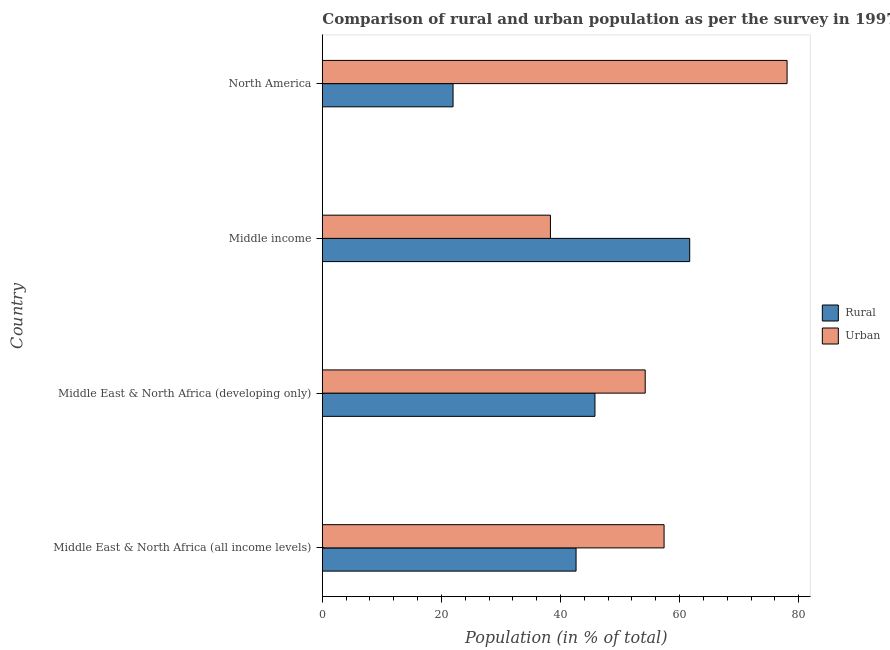Are the number of bars per tick equal to the number of legend labels?
Your answer should be very brief. Yes. How many bars are there on the 1st tick from the top?
Keep it short and to the point. 2. What is the urban population in Middle East & North Africa (all income levels)?
Provide a short and direct response. 57.39. Across all countries, what is the maximum rural population?
Your answer should be very brief. 61.69. Across all countries, what is the minimum rural population?
Ensure brevity in your answer.  21.95. In which country was the rural population maximum?
Offer a terse response. Middle income. What is the total urban population in the graph?
Offer a very short reply. 227.96. What is the difference between the urban population in Middle East & North Africa (all income levels) and that in Middle income?
Give a very brief answer. 19.08. What is the difference between the urban population in Middle income and the rural population in North America?
Your response must be concise. 16.35. What is the average rural population per country?
Make the answer very short. 43.01. What is the difference between the urban population and rural population in Middle income?
Your answer should be compact. -23.39. Is the difference between the urban population in Middle income and North America greater than the difference between the rural population in Middle income and North America?
Offer a terse response. No. What is the difference between the highest and the second highest urban population?
Offer a terse response. 20.66. What is the difference between the highest and the lowest urban population?
Ensure brevity in your answer.  39.74. What does the 2nd bar from the top in North America represents?
Ensure brevity in your answer.  Rural. What does the 1st bar from the bottom in Middle East & North Africa (all income levels) represents?
Your response must be concise. Rural. How many bars are there?
Your response must be concise. 8. Are all the bars in the graph horizontal?
Your answer should be compact. Yes. How many countries are there in the graph?
Give a very brief answer. 4. What is the difference between two consecutive major ticks on the X-axis?
Your answer should be compact. 20. Does the graph contain any zero values?
Ensure brevity in your answer.  No. Does the graph contain grids?
Provide a succinct answer. No. How many legend labels are there?
Ensure brevity in your answer.  2. What is the title of the graph?
Give a very brief answer. Comparison of rural and urban population as per the survey in 1997 census. Does "Diarrhea" appear as one of the legend labels in the graph?
Give a very brief answer. No. What is the label or title of the X-axis?
Keep it short and to the point. Population (in % of total). What is the label or title of the Y-axis?
Keep it short and to the point. Country. What is the Population (in % of total) in Rural in Middle East & North Africa (all income levels)?
Offer a terse response. 42.61. What is the Population (in % of total) of Urban in Middle East & North Africa (all income levels)?
Your answer should be very brief. 57.39. What is the Population (in % of total) in Rural in Middle East & North Africa (developing only)?
Keep it short and to the point. 45.78. What is the Population (in % of total) in Urban in Middle East & North Africa (developing only)?
Your response must be concise. 54.22. What is the Population (in % of total) in Rural in Middle income?
Ensure brevity in your answer.  61.69. What is the Population (in % of total) in Urban in Middle income?
Ensure brevity in your answer.  38.31. What is the Population (in % of total) in Rural in North America?
Provide a succinct answer. 21.95. What is the Population (in % of total) of Urban in North America?
Your answer should be compact. 78.05. Across all countries, what is the maximum Population (in % of total) of Rural?
Offer a terse response. 61.69. Across all countries, what is the maximum Population (in % of total) in Urban?
Provide a short and direct response. 78.05. Across all countries, what is the minimum Population (in % of total) in Rural?
Keep it short and to the point. 21.95. Across all countries, what is the minimum Population (in % of total) of Urban?
Your answer should be compact. 38.31. What is the total Population (in % of total) in Rural in the graph?
Your answer should be compact. 172.04. What is the total Population (in % of total) in Urban in the graph?
Ensure brevity in your answer.  227.96. What is the difference between the Population (in % of total) in Rural in Middle East & North Africa (all income levels) and that in Middle East & North Africa (developing only)?
Your answer should be compact. -3.17. What is the difference between the Population (in % of total) of Urban in Middle East & North Africa (all income levels) and that in Middle East & North Africa (developing only)?
Your answer should be very brief. 3.17. What is the difference between the Population (in % of total) of Rural in Middle East & North Africa (all income levels) and that in Middle income?
Offer a terse response. -19.08. What is the difference between the Population (in % of total) in Urban in Middle East & North Africa (all income levels) and that in Middle income?
Offer a terse response. 19.08. What is the difference between the Population (in % of total) of Rural in Middle East & North Africa (all income levels) and that in North America?
Your answer should be compact. 20.65. What is the difference between the Population (in % of total) in Urban in Middle East & North Africa (all income levels) and that in North America?
Make the answer very short. -20.65. What is the difference between the Population (in % of total) of Rural in Middle East & North Africa (developing only) and that in Middle income?
Ensure brevity in your answer.  -15.91. What is the difference between the Population (in % of total) in Urban in Middle East & North Africa (developing only) and that in Middle income?
Provide a succinct answer. 15.91. What is the difference between the Population (in % of total) in Rural in Middle East & North Africa (developing only) and that in North America?
Offer a terse response. 23.83. What is the difference between the Population (in % of total) in Urban in Middle East & North Africa (developing only) and that in North America?
Your response must be concise. -23.83. What is the difference between the Population (in % of total) in Rural in Middle income and that in North America?
Your response must be concise. 39.74. What is the difference between the Population (in % of total) of Urban in Middle income and that in North America?
Offer a very short reply. -39.74. What is the difference between the Population (in % of total) of Rural in Middle East & North Africa (all income levels) and the Population (in % of total) of Urban in Middle East & North Africa (developing only)?
Provide a short and direct response. -11.61. What is the difference between the Population (in % of total) of Rural in Middle East & North Africa (all income levels) and the Population (in % of total) of Urban in Middle income?
Your answer should be compact. 4.3. What is the difference between the Population (in % of total) of Rural in Middle East & North Africa (all income levels) and the Population (in % of total) of Urban in North America?
Ensure brevity in your answer.  -35.44. What is the difference between the Population (in % of total) in Rural in Middle East & North Africa (developing only) and the Population (in % of total) in Urban in Middle income?
Give a very brief answer. 7.48. What is the difference between the Population (in % of total) of Rural in Middle East & North Africa (developing only) and the Population (in % of total) of Urban in North America?
Offer a terse response. -32.26. What is the difference between the Population (in % of total) of Rural in Middle income and the Population (in % of total) of Urban in North America?
Provide a short and direct response. -16.35. What is the average Population (in % of total) of Rural per country?
Make the answer very short. 43.01. What is the average Population (in % of total) in Urban per country?
Ensure brevity in your answer.  56.99. What is the difference between the Population (in % of total) of Rural and Population (in % of total) of Urban in Middle East & North Africa (all income levels)?
Your response must be concise. -14.78. What is the difference between the Population (in % of total) of Rural and Population (in % of total) of Urban in Middle East & North Africa (developing only)?
Make the answer very short. -8.44. What is the difference between the Population (in % of total) in Rural and Population (in % of total) in Urban in Middle income?
Your answer should be very brief. 23.39. What is the difference between the Population (in % of total) in Rural and Population (in % of total) in Urban in North America?
Your answer should be very brief. -56.09. What is the ratio of the Population (in % of total) in Rural in Middle East & North Africa (all income levels) to that in Middle East & North Africa (developing only)?
Your answer should be compact. 0.93. What is the ratio of the Population (in % of total) in Urban in Middle East & North Africa (all income levels) to that in Middle East & North Africa (developing only)?
Provide a succinct answer. 1.06. What is the ratio of the Population (in % of total) of Rural in Middle East & North Africa (all income levels) to that in Middle income?
Your answer should be very brief. 0.69. What is the ratio of the Population (in % of total) in Urban in Middle East & North Africa (all income levels) to that in Middle income?
Offer a terse response. 1.5. What is the ratio of the Population (in % of total) in Rural in Middle East & North Africa (all income levels) to that in North America?
Your response must be concise. 1.94. What is the ratio of the Population (in % of total) in Urban in Middle East & North Africa (all income levels) to that in North America?
Give a very brief answer. 0.74. What is the ratio of the Population (in % of total) of Rural in Middle East & North Africa (developing only) to that in Middle income?
Ensure brevity in your answer.  0.74. What is the ratio of the Population (in % of total) of Urban in Middle East & North Africa (developing only) to that in Middle income?
Ensure brevity in your answer.  1.42. What is the ratio of the Population (in % of total) of Rural in Middle East & North Africa (developing only) to that in North America?
Keep it short and to the point. 2.09. What is the ratio of the Population (in % of total) in Urban in Middle East & North Africa (developing only) to that in North America?
Your answer should be compact. 0.69. What is the ratio of the Population (in % of total) of Rural in Middle income to that in North America?
Make the answer very short. 2.81. What is the ratio of the Population (in % of total) in Urban in Middle income to that in North America?
Your response must be concise. 0.49. What is the difference between the highest and the second highest Population (in % of total) of Rural?
Provide a succinct answer. 15.91. What is the difference between the highest and the second highest Population (in % of total) in Urban?
Give a very brief answer. 20.65. What is the difference between the highest and the lowest Population (in % of total) of Rural?
Your answer should be very brief. 39.74. What is the difference between the highest and the lowest Population (in % of total) of Urban?
Offer a very short reply. 39.74. 